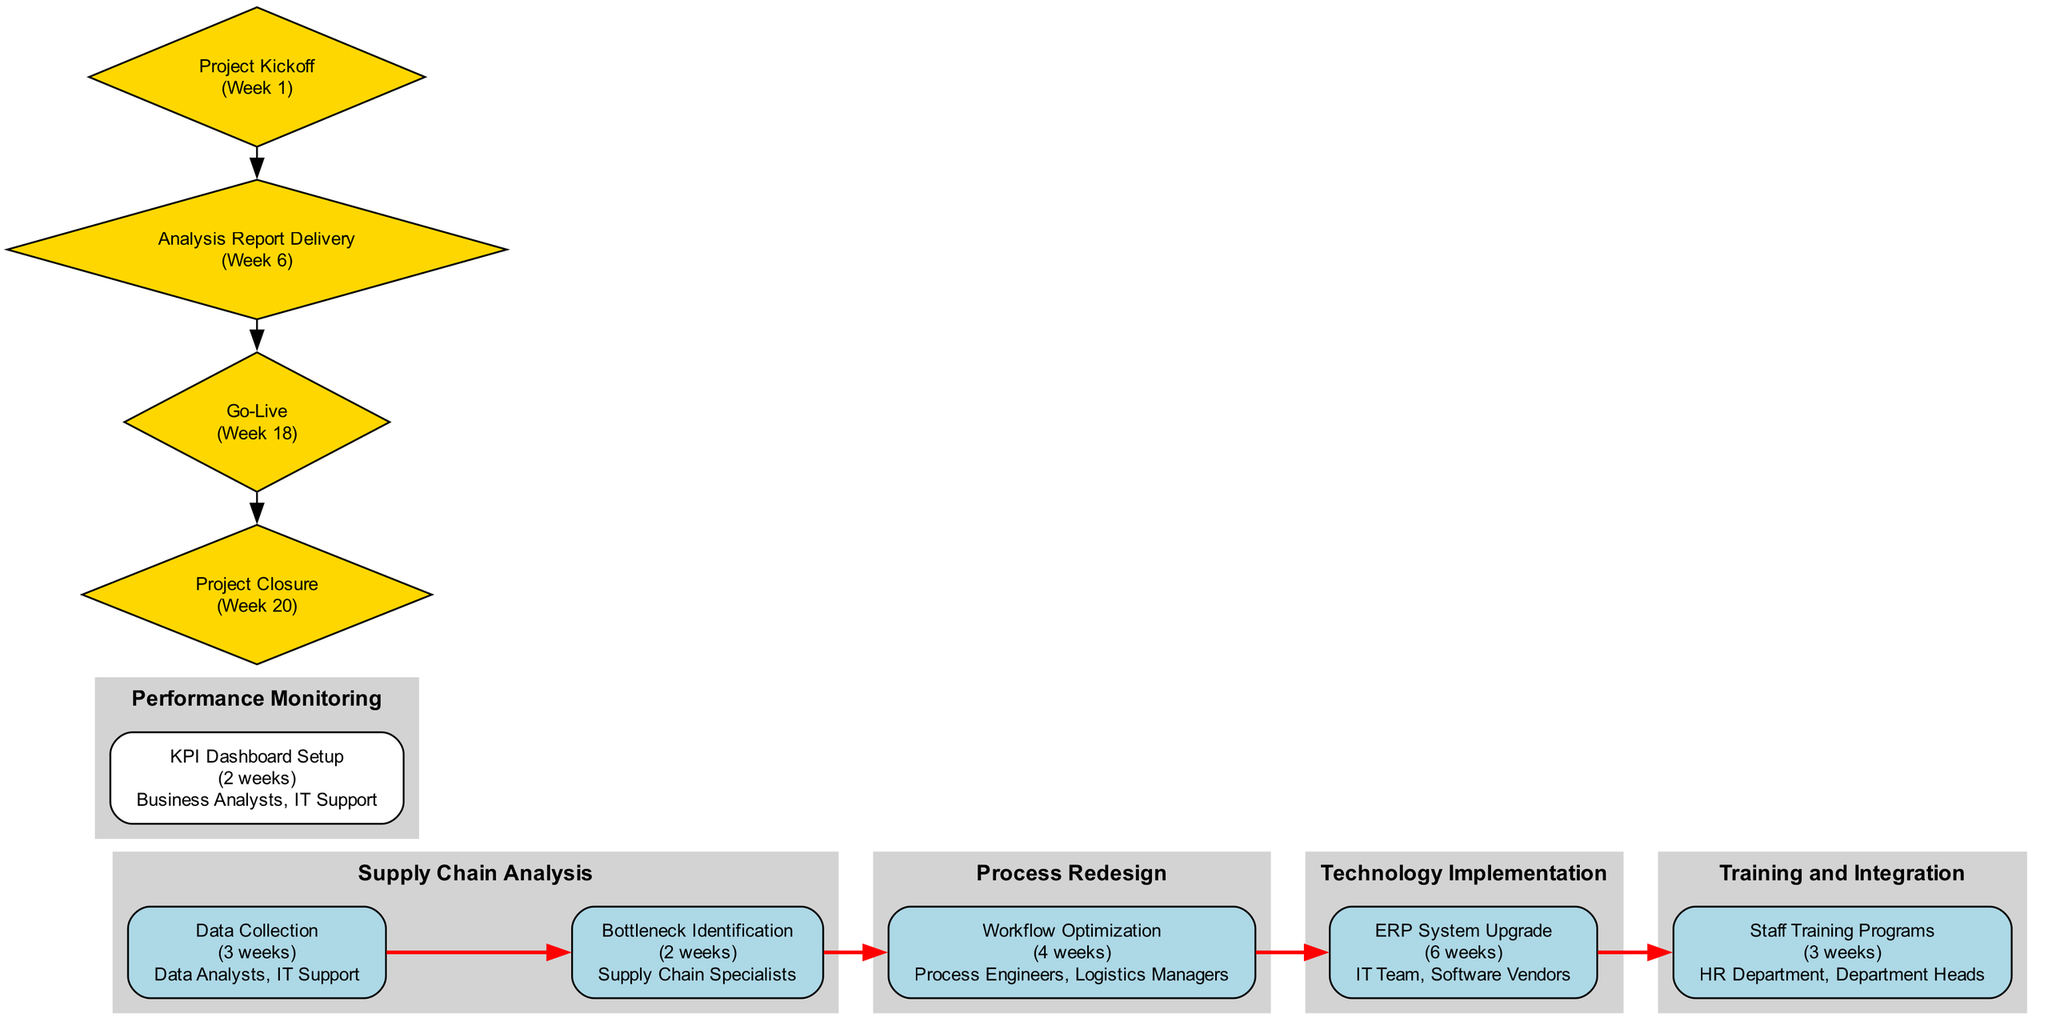What are the project phases depicted in the diagram? The project phases are shown as distinct clusters within the diagram. By identifying the individual subgraphs labeled as "Supply Chain Analysis," "Process Redesign," "Technology Implementation," "Training and Integration," and "Performance Monitoring," we can list them.
Answer: Supply Chain Analysis, Process Redesign, Technology Implementation, Training and Integration, Performance Monitoring How many tasks are listed under the "Technology Implementation" phase? To determine the number of tasks, I reference the tasks and look for those categorized under "Technology Implementation." By counting, I find there is only one task, "ERP System Upgrade."
Answer: 1 Which task has the longest duration in weeks? By comparing the durations of all tasks provided in the diagram, I identify "ERP System Upgrade," which lasts 6 weeks, as the longest.
Answer: ERP System Upgrade What is the critical path of the project? The critical path is explicitly mentioned in the diagram and highlights the sequence of tasks that must be completed on time to prevent project delays. I can list them directly from this sequence as depicted.
Answer: Data Collection, Bottleneck Identification, Workflow Optimization, ERP System Upgrade, Staff Training Programs What milestone is scheduled for Week 6? The milestones are presented within the diagram. By checking for the milestone that corresponds to Week 6, I clearly identify "Analysis Report Delivery."
Answer: Analysis Report Delivery Which resources are allocated to the "Data Collection" task? By examining the "Data Collection" task, I see that it specifies the associated resources, which are mentioned as "Data Analysts" and "IT Support."
Answer: Data Analysts, IT Support Which task is performed after "Workflow Optimization" in the critical path? The critical path outlines the sequence of tasks. Following "Workflow Optimization," I observe "ERP System Upgrade" as the subsequent task in the critical path.
Answer: ERP System Upgrade How many total milestones are in the diagram? The milestones are outlined as diamond-shaped nodes within the diagram. By counting them, I find that there are four milestones illustrated.
Answer: 4 